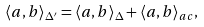<formula> <loc_0><loc_0><loc_500><loc_500>\langle a , b \rangle _ { \Delta ^ { \prime } } = \langle a , b \rangle _ { \Delta } + \langle a , b \rangle _ { a c } ,</formula> 